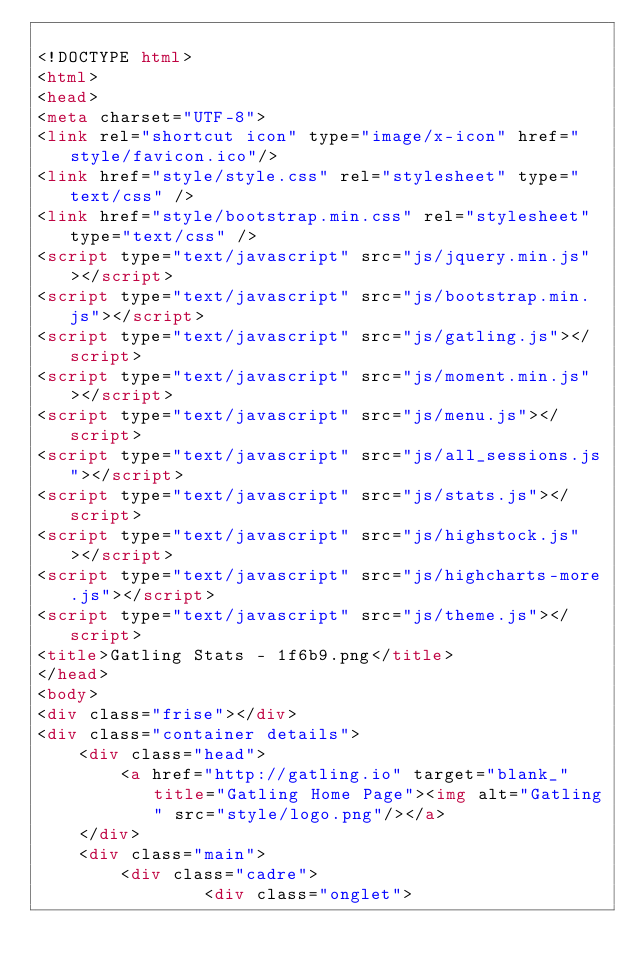Convert code to text. <code><loc_0><loc_0><loc_500><loc_500><_HTML_>
<!DOCTYPE html>
<html>
<head>
<meta charset="UTF-8">
<link rel="shortcut icon" type="image/x-icon" href="style/favicon.ico"/>
<link href="style/style.css" rel="stylesheet" type="text/css" />
<link href="style/bootstrap.min.css" rel="stylesheet" type="text/css" />
<script type="text/javascript" src="js/jquery.min.js"></script>
<script type="text/javascript" src="js/bootstrap.min.js"></script>
<script type="text/javascript" src="js/gatling.js"></script>
<script type="text/javascript" src="js/moment.min.js"></script>
<script type="text/javascript" src="js/menu.js"></script>
<script type="text/javascript" src="js/all_sessions.js"></script>
<script type="text/javascript" src="js/stats.js"></script>
<script type="text/javascript" src="js/highstock.js"></script>
<script type="text/javascript" src="js/highcharts-more.js"></script>
<script type="text/javascript" src="js/theme.js"></script>
<title>Gatling Stats - 1f6b9.png</title>
</head>
<body>
<div class="frise"></div>
<div class="container details">
    <div class="head">
        <a href="http://gatling.io" target="blank_" title="Gatling Home Page"><img alt="Gatling" src="style/logo.png"/></a>
    </div>
    <div class="main">
        <div class="cadre">
                <div class="onglet"></code> 